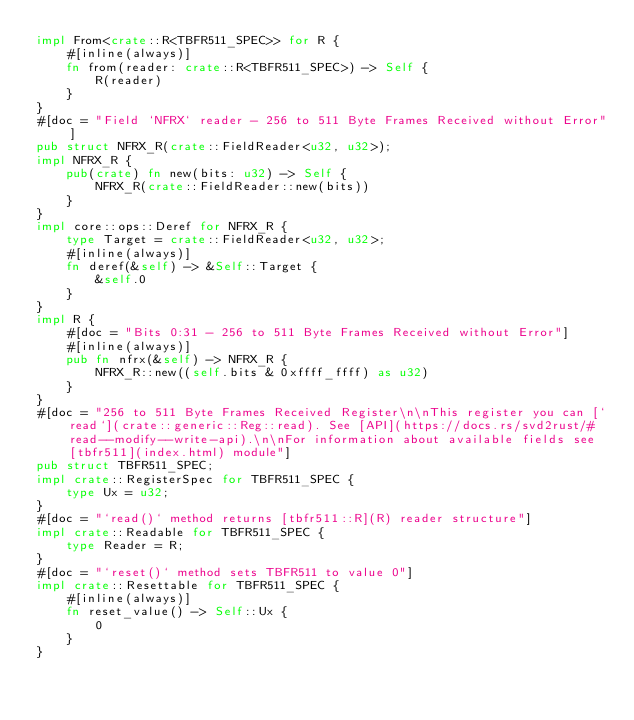<code> <loc_0><loc_0><loc_500><loc_500><_Rust_>impl From<crate::R<TBFR511_SPEC>> for R {
    #[inline(always)]
    fn from(reader: crate::R<TBFR511_SPEC>) -> Self {
        R(reader)
    }
}
#[doc = "Field `NFRX` reader - 256 to 511 Byte Frames Received without Error"]
pub struct NFRX_R(crate::FieldReader<u32, u32>);
impl NFRX_R {
    pub(crate) fn new(bits: u32) -> Self {
        NFRX_R(crate::FieldReader::new(bits))
    }
}
impl core::ops::Deref for NFRX_R {
    type Target = crate::FieldReader<u32, u32>;
    #[inline(always)]
    fn deref(&self) -> &Self::Target {
        &self.0
    }
}
impl R {
    #[doc = "Bits 0:31 - 256 to 511 Byte Frames Received without Error"]
    #[inline(always)]
    pub fn nfrx(&self) -> NFRX_R {
        NFRX_R::new((self.bits & 0xffff_ffff) as u32)
    }
}
#[doc = "256 to 511 Byte Frames Received Register\n\nThis register you can [`read`](crate::generic::Reg::read). See [API](https://docs.rs/svd2rust/#read--modify--write-api).\n\nFor information about available fields see [tbfr511](index.html) module"]
pub struct TBFR511_SPEC;
impl crate::RegisterSpec for TBFR511_SPEC {
    type Ux = u32;
}
#[doc = "`read()` method returns [tbfr511::R](R) reader structure"]
impl crate::Readable for TBFR511_SPEC {
    type Reader = R;
}
#[doc = "`reset()` method sets TBFR511 to value 0"]
impl crate::Resettable for TBFR511_SPEC {
    #[inline(always)]
    fn reset_value() -> Self::Ux {
        0
    }
}
</code> 